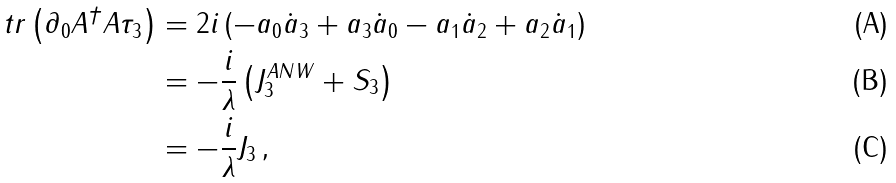<formula> <loc_0><loc_0><loc_500><loc_500>t r \left ( \partial _ { 0 } A ^ { \dag } A \tau _ { 3 } \right ) & = 2 i \left ( - a _ { 0 } \dot { a } _ { 3 } + a _ { 3 } \dot { a } _ { 0 } - a _ { 1 } \dot { a } _ { 2 } + a _ { 2 } \dot { a } _ { 1 } \right ) \\ & = - \frac { i } { \lambda } \left ( J _ { 3 } ^ { A N W } + S _ { 3 } \right ) \\ & = - \frac { i } { \lambda } J _ { 3 } \, ,</formula> 